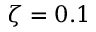Convert formula to latex. <formula><loc_0><loc_0><loc_500><loc_500>\zeta = 0 . 1</formula> 